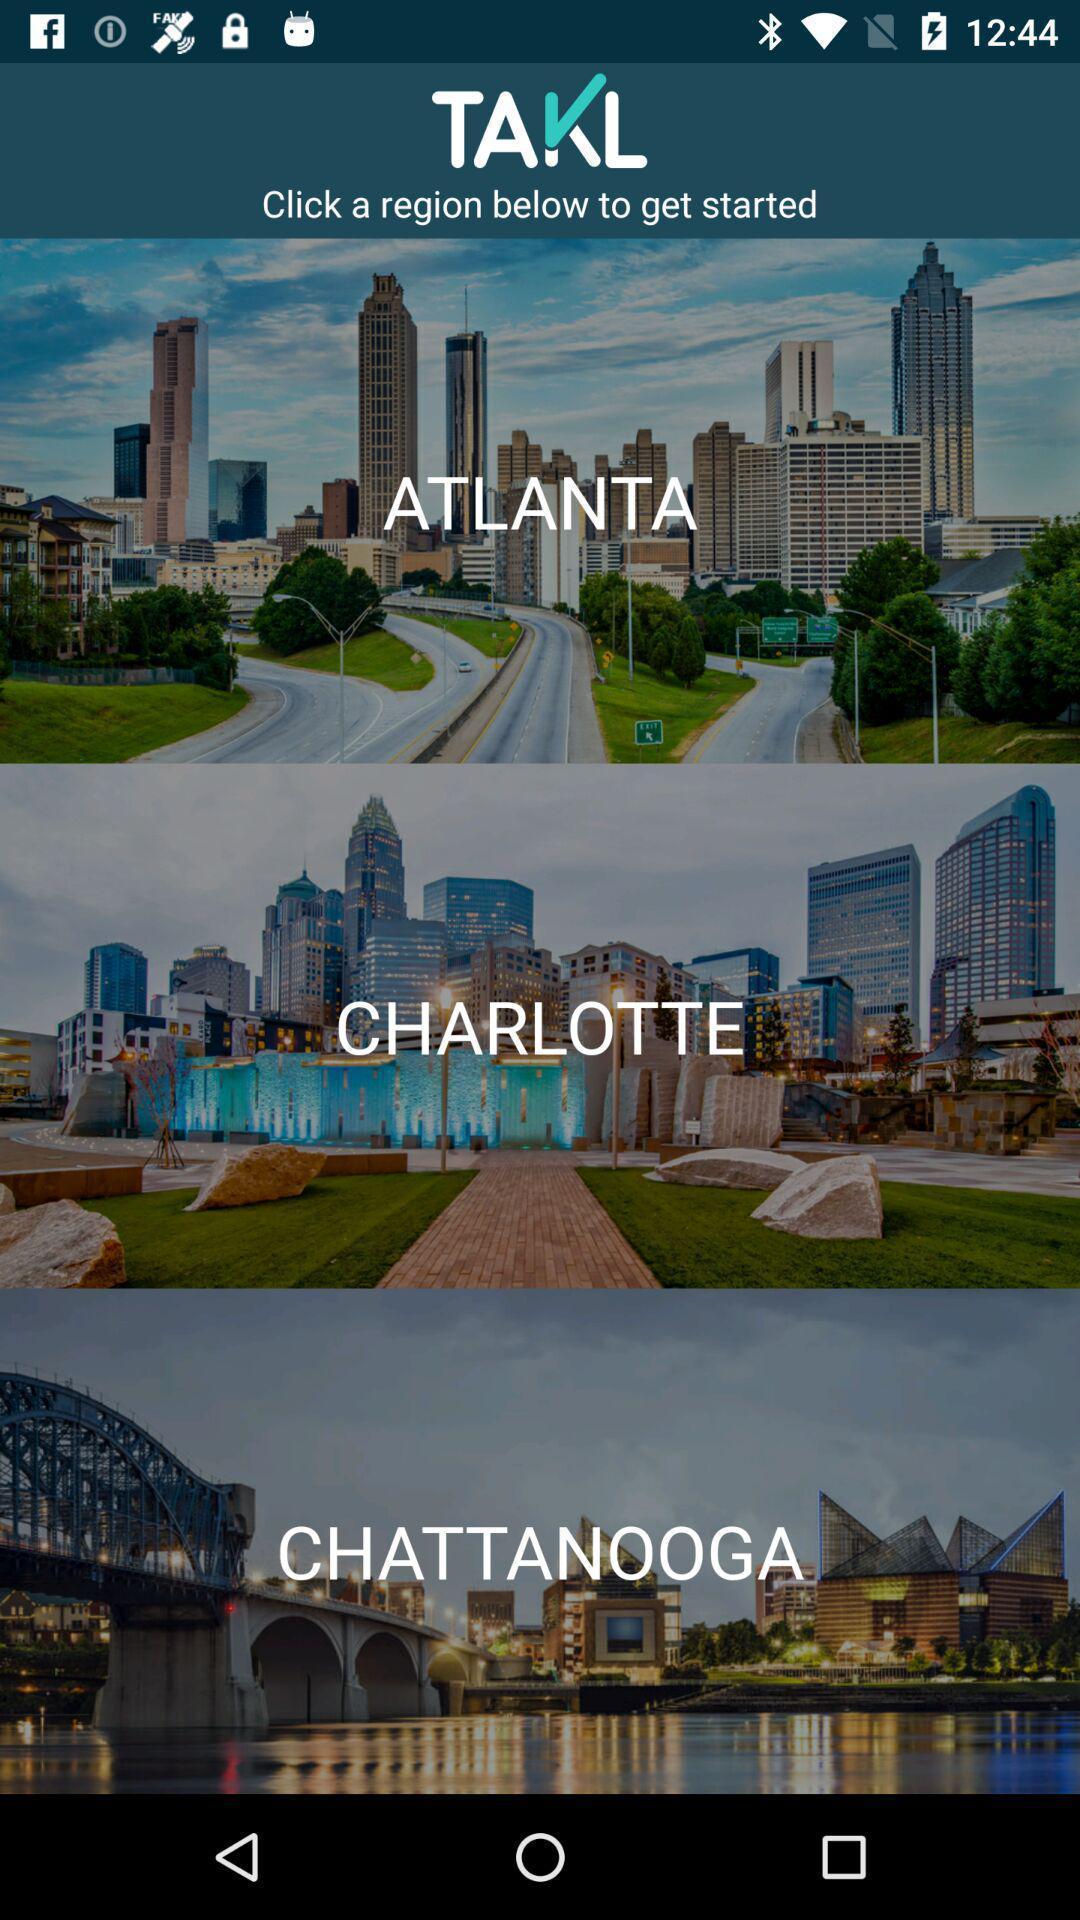What details can you identify in this image? Welcome page. 